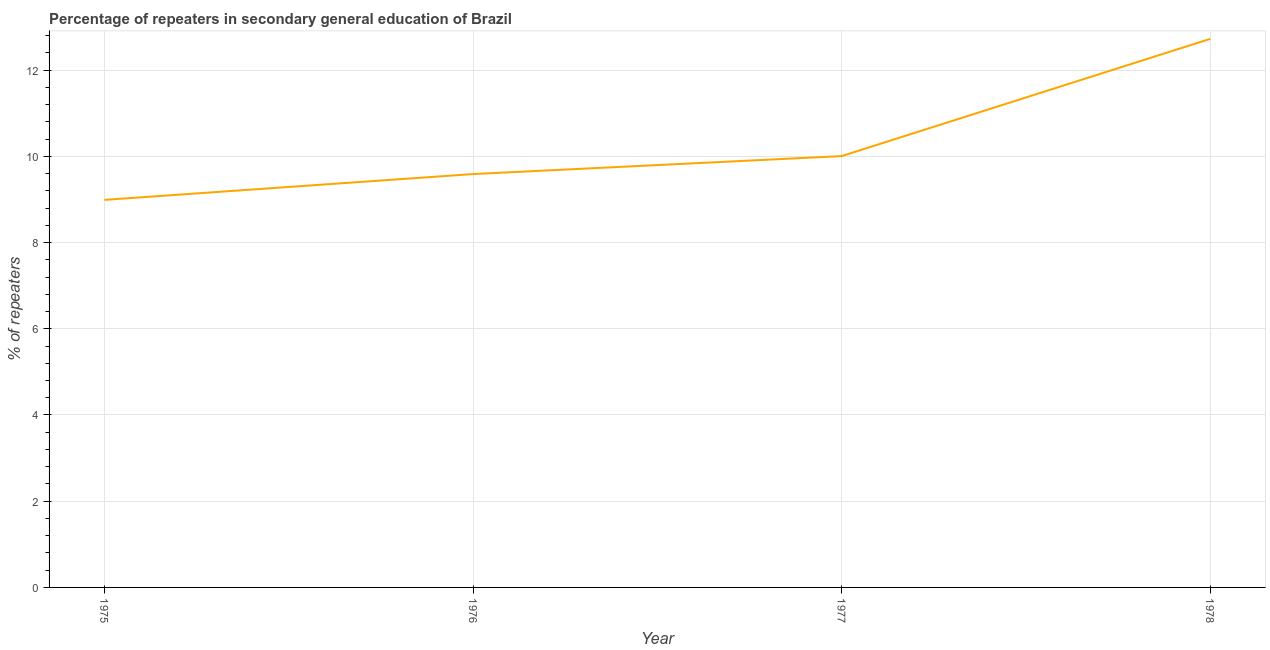What is the percentage of repeaters in 1976?
Your response must be concise. 9.59. Across all years, what is the maximum percentage of repeaters?
Provide a short and direct response. 12.73. Across all years, what is the minimum percentage of repeaters?
Keep it short and to the point. 8.99. In which year was the percentage of repeaters maximum?
Keep it short and to the point. 1978. In which year was the percentage of repeaters minimum?
Give a very brief answer. 1975. What is the sum of the percentage of repeaters?
Ensure brevity in your answer.  41.31. What is the difference between the percentage of repeaters in 1977 and 1978?
Ensure brevity in your answer.  -2.72. What is the average percentage of repeaters per year?
Make the answer very short. 10.33. What is the median percentage of repeaters?
Offer a terse response. 9.8. What is the ratio of the percentage of repeaters in 1976 to that in 1978?
Give a very brief answer. 0.75. Is the difference between the percentage of repeaters in 1975 and 1978 greater than the difference between any two years?
Provide a short and direct response. Yes. What is the difference between the highest and the second highest percentage of repeaters?
Your answer should be compact. 2.72. What is the difference between the highest and the lowest percentage of repeaters?
Your response must be concise. 3.73. How many lines are there?
Your response must be concise. 1. Does the graph contain any zero values?
Your answer should be compact. No. What is the title of the graph?
Ensure brevity in your answer.  Percentage of repeaters in secondary general education of Brazil. What is the label or title of the Y-axis?
Ensure brevity in your answer.  % of repeaters. What is the % of repeaters of 1975?
Your response must be concise. 8.99. What is the % of repeaters of 1976?
Provide a succinct answer. 9.59. What is the % of repeaters of 1977?
Make the answer very short. 10.01. What is the % of repeaters in 1978?
Ensure brevity in your answer.  12.73. What is the difference between the % of repeaters in 1975 and 1976?
Your answer should be compact. -0.6. What is the difference between the % of repeaters in 1975 and 1977?
Your answer should be very brief. -1.02. What is the difference between the % of repeaters in 1975 and 1978?
Make the answer very short. -3.73. What is the difference between the % of repeaters in 1976 and 1977?
Provide a succinct answer. -0.42. What is the difference between the % of repeaters in 1976 and 1978?
Keep it short and to the point. -3.14. What is the difference between the % of repeaters in 1977 and 1978?
Ensure brevity in your answer.  -2.72. What is the ratio of the % of repeaters in 1975 to that in 1976?
Offer a very short reply. 0.94. What is the ratio of the % of repeaters in 1975 to that in 1977?
Offer a very short reply. 0.9. What is the ratio of the % of repeaters in 1975 to that in 1978?
Your response must be concise. 0.71. What is the ratio of the % of repeaters in 1976 to that in 1977?
Offer a terse response. 0.96. What is the ratio of the % of repeaters in 1976 to that in 1978?
Your answer should be compact. 0.75. What is the ratio of the % of repeaters in 1977 to that in 1978?
Your response must be concise. 0.79. 